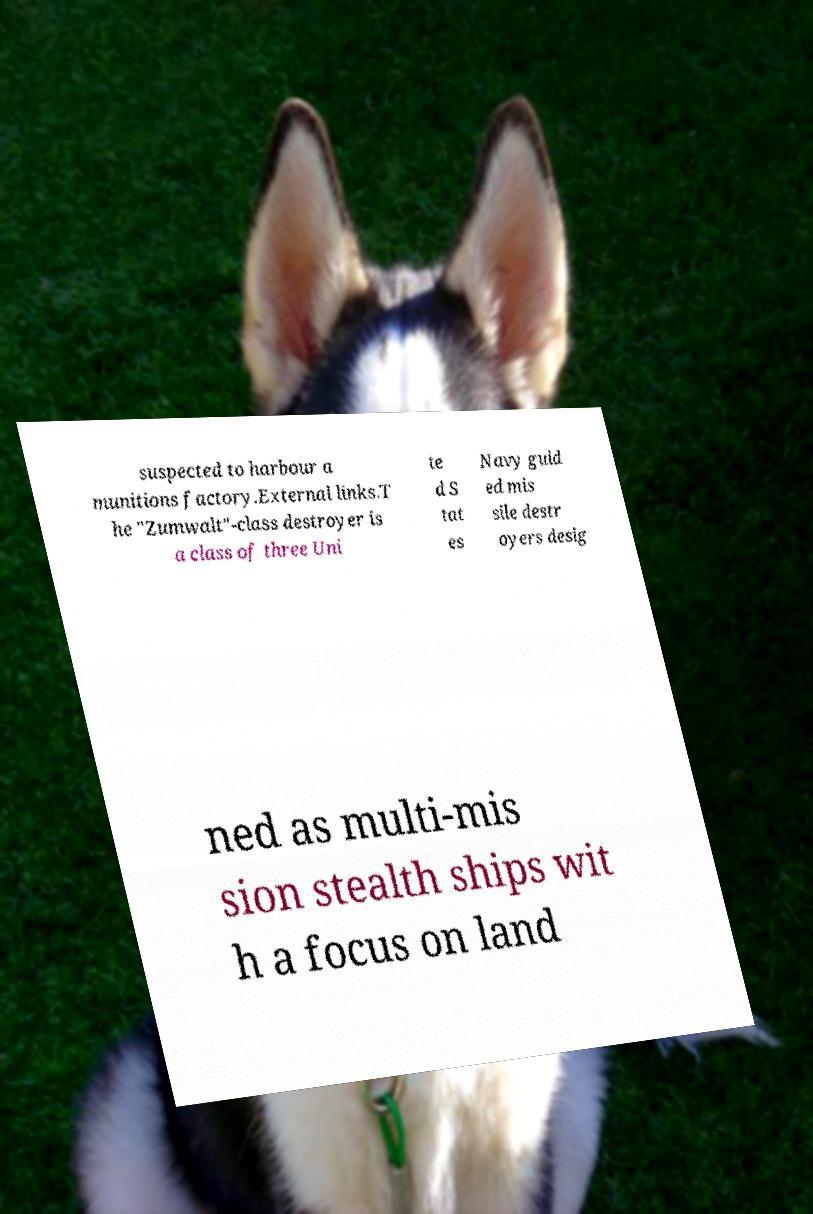There's text embedded in this image that I need extracted. Can you transcribe it verbatim? suspected to harbour a munitions factory.External links.T he "Zumwalt"-class destroyer is a class of three Uni te d S tat es Navy guid ed mis sile destr oyers desig ned as multi-mis sion stealth ships wit h a focus on land 